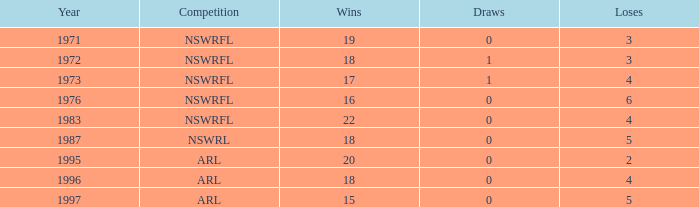What highest Year has Wins 15 and Losses less than 5? None. 